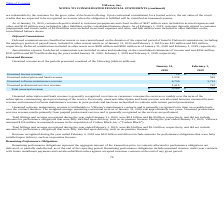According to Vmware's financial document, What was unearned software maintenance revenue attributable to? VMware’s maintenance contracts. The document states: "d software maintenance revenue is attributable to VMware’s maintenance contracts and is generally recognized over time on a ratable basis..." Also, What is unearned professional services revenue the result of? prepaid professional services and is generally recognized as the services are performed. The document states: "fessional services revenue results primarily from prepaid professional services and is generally recognized as the services are performed...." Also, What was the total billings recognized during the year ended 2020? According to the financial document, $8.1 billion. The relevant text states: "nized during the year ended January 31, 2020, were $8.1 billion and $6.4 billion, respectively, and did not include..." Also, can you calculate: What was the change in unearned license revenue between 2019 and 2020? Based on the calculation: 19-15, the result is 4 (in millions). This is based on the information: "consolidated balance sheets. As of February 1, 2019, customer deposits related to customer prepayments and cloud credits of $239 million were included , 2020 and February 1, 2019 were $13 million and ..." The key data points involved are: 15, 19. Also, can you calculate: What was the change in Unearned software maintenance revenue between 2019 and 2020? Based on the calculation: 6,700-5,741, the result is 959 (in millions). This is based on the information: "Unearned software maintenance revenue 6,700 5,741 Unearned software maintenance revenue 6,700 5,741..." The key data points involved are: 5,741, 6,700. Also, can you calculate: What was the percentage of total unearned revenue between 2019 and 2020? To answer this question, I need to perform calculations using the financial data. The calculation is: (9,268-7,439)/7,439, which equals 24.59 (percentage). This is based on the information: "Total unearned revenue $ 9,268 $ 7,439 Total unearned revenue $ 9,268 $ 7,439..." The key data points involved are: 7,439, 9,268. 